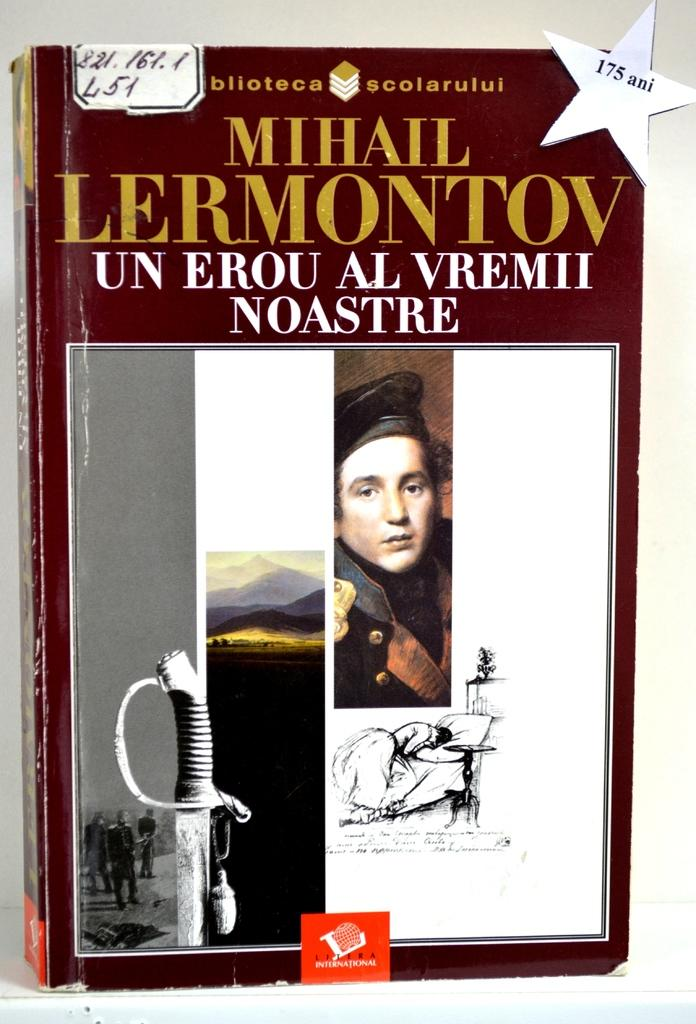<image>
Relay a brief, clear account of the picture shown. The book Un Erou Al Vremii Noastre was written by Mihail Lermontov. 